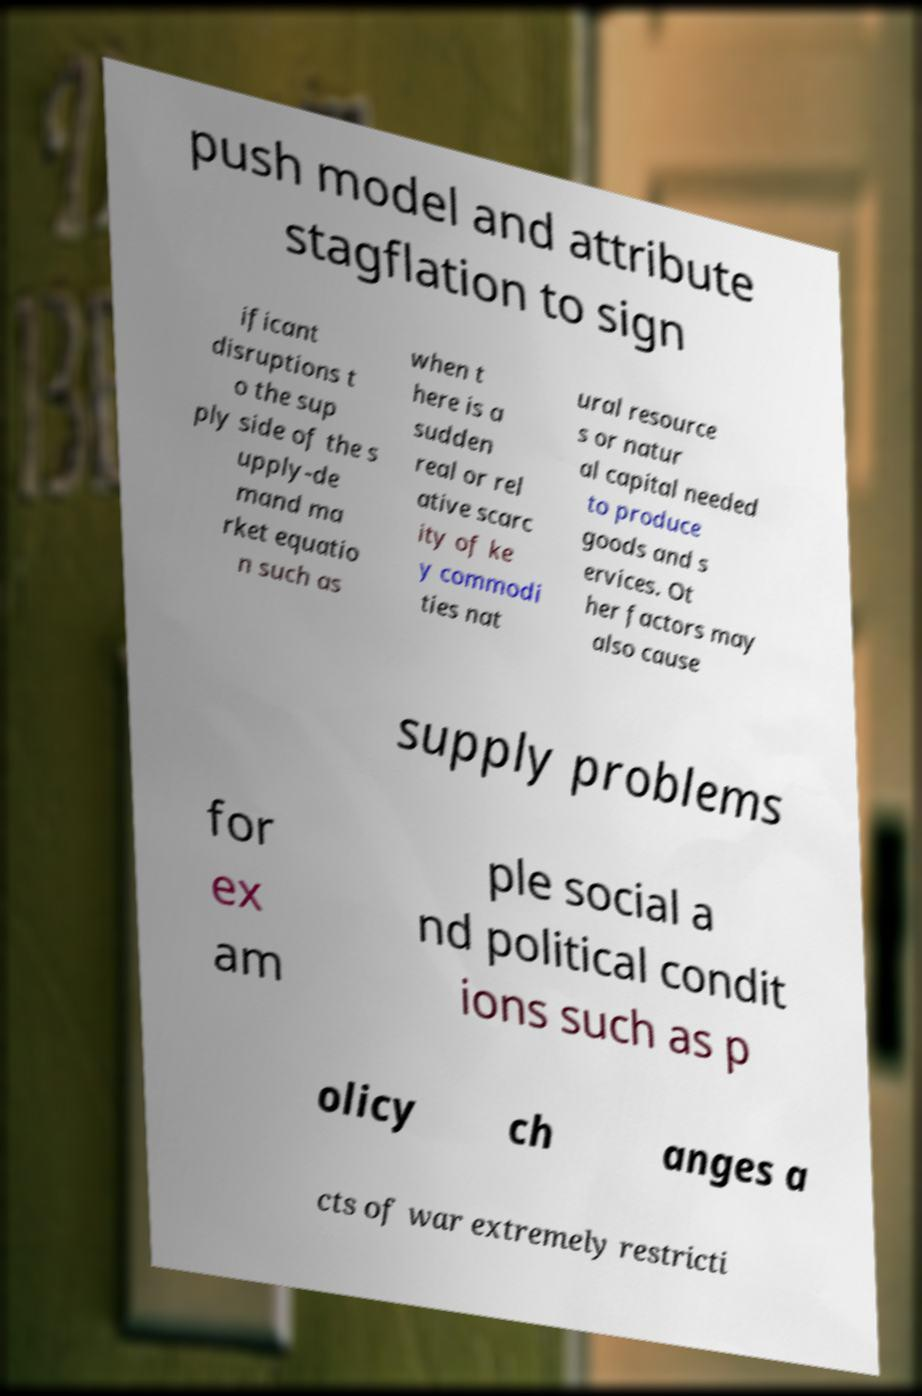What messages or text are displayed in this image? I need them in a readable, typed format. push model and attribute stagflation to sign ificant disruptions t o the sup ply side of the s upply-de mand ma rket equatio n such as when t here is a sudden real or rel ative scarc ity of ke y commodi ties nat ural resource s or natur al capital needed to produce goods and s ervices. Ot her factors may also cause supply problems for ex am ple social a nd political condit ions such as p olicy ch anges a cts of war extremely restricti 